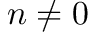Convert formula to latex. <formula><loc_0><loc_0><loc_500><loc_500>n \neq 0</formula> 